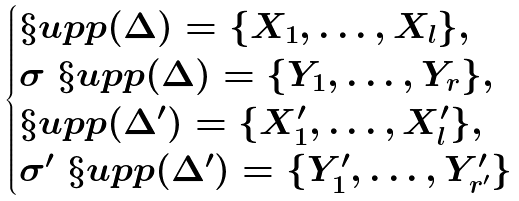<formula> <loc_0><loc_0><loc_500><loc_500>\begin{cases} \S u p p ( \Delta ) = \{ X _ { 1 } , \dots , X _ { l } \} , \\ \sigma \ \S u p p ( \Delta ) = \{ Y _ { 1 } , \dots , Y _ { r } \} , \\ \S u p p ( \Delta ^ { \prime } ) = \{ X ^ { \prime } _ { 1 } , \dots , X ^ { \prime } _ { l } \} , \\ \sigma ^ { \prime } \ \S u p p ( \Delta ^ { \prime } ) = \{ Y ^ { \prime } _ { 1 } , \dots , Y ^ { \prime } _ { r ^ { \prime } } \} \end{cases}</formula> 